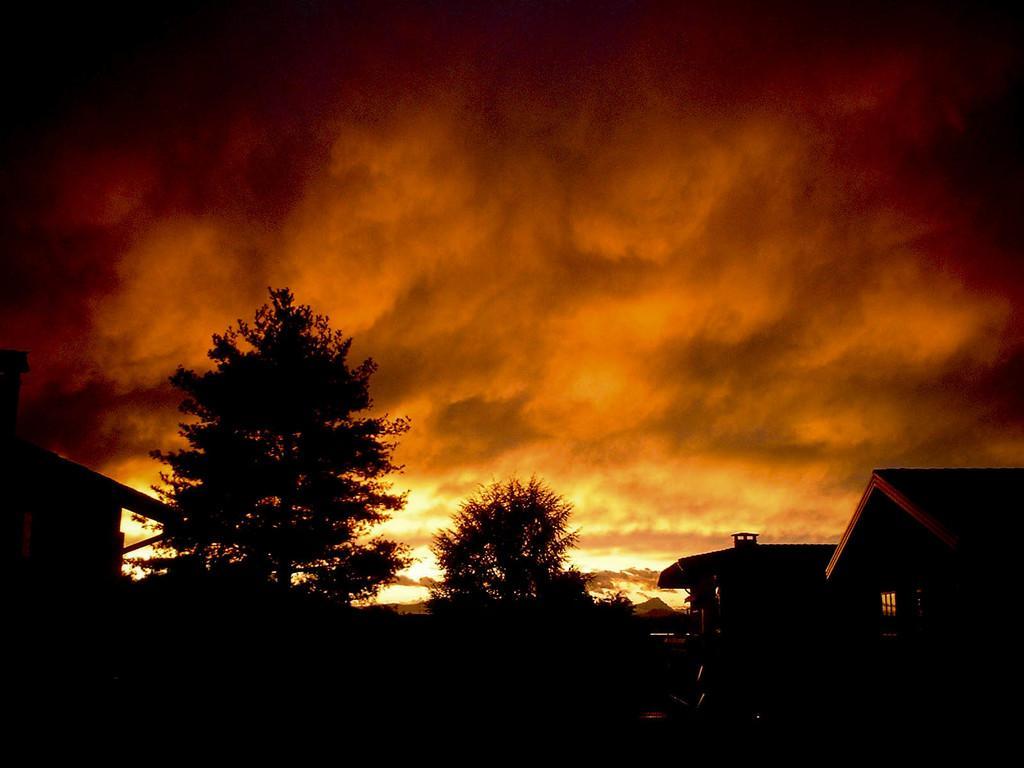Describe this image in one or two sentences. In this image we can see houses,trees. At the top of the image there is sky and clouds. 